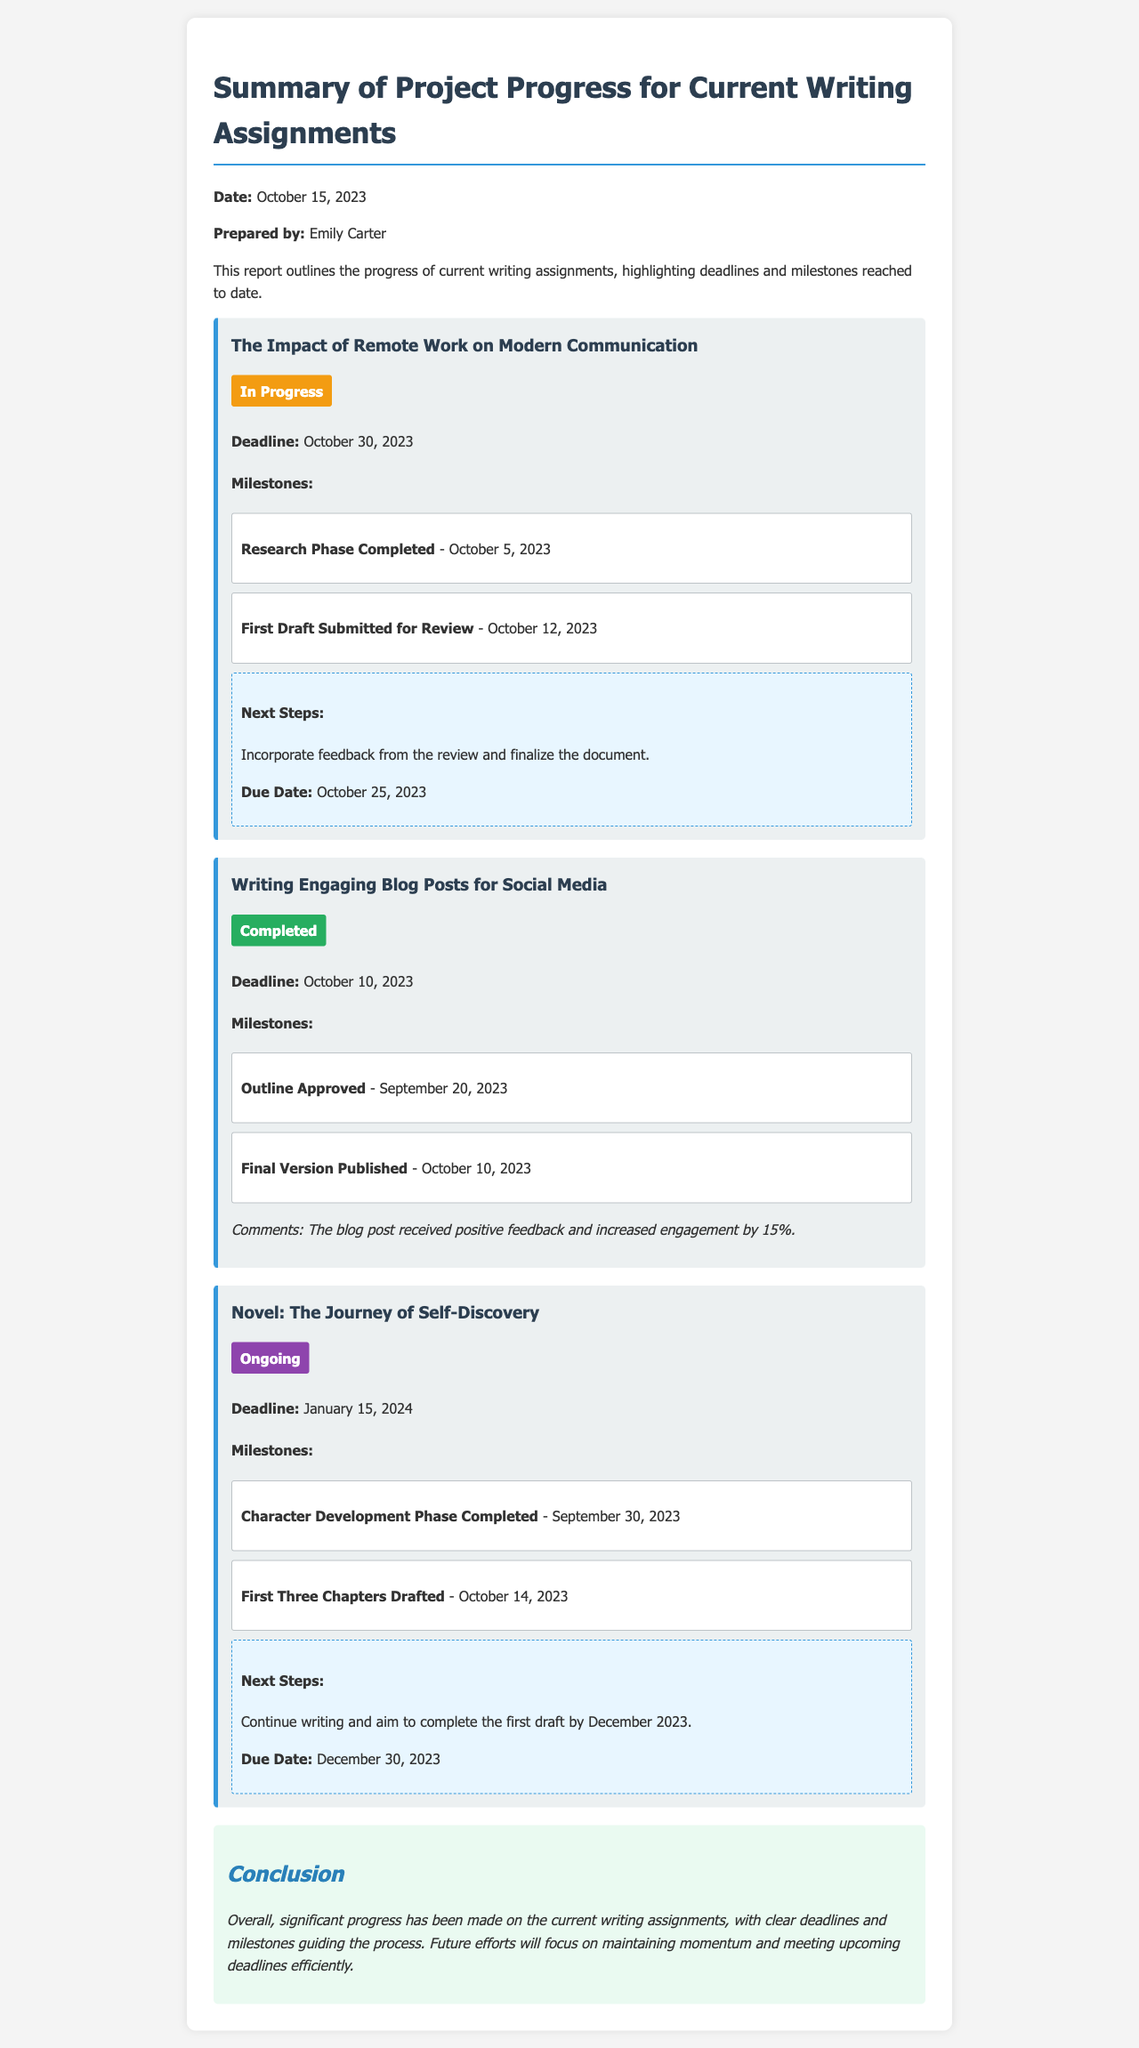What is the date of the report? The date of the report is mentioned at the beginning of the document, which is October 15, 2023.
Answer: October 15, 2023 Who prepared the report? The report states the author at the beginning, which is Emily Carter.
Answer: Emily Carter What is the status of "The Impact of Remote Work on Modern Communication"? The report indicates the status of the project, which is "In Progress".
Answer: In Progress What milestone was completed for the "Writing Engaging Blog Posts for Social Media"? The document lists milestones, where one milestone completed is "Final Version Published".
Answer: Final Version Published What is the next step for "Novel: The Journey of Self-Discovery"? The next steps are outlined for the project, indicating it is to "Continue writing and aim to complete the first draft by December 2023."
Answer: Continue writing and aim to complete the first draft by December 2023 What was the feedback on the blog post? The document contains comments that the blog post received positive feedback and increased engagement by 15%.
Answer: Increased engagement by 15% What is the deadline for "The Impact of Remote Work on Modern Communication"? The deadline for this project is specified in the document as October 30, 2023.
Answer: October 30, 2023 How many projects are mentioned in the report? The report outlines three different writing projects currently in progress, hence the number is three.
Answer: Three 